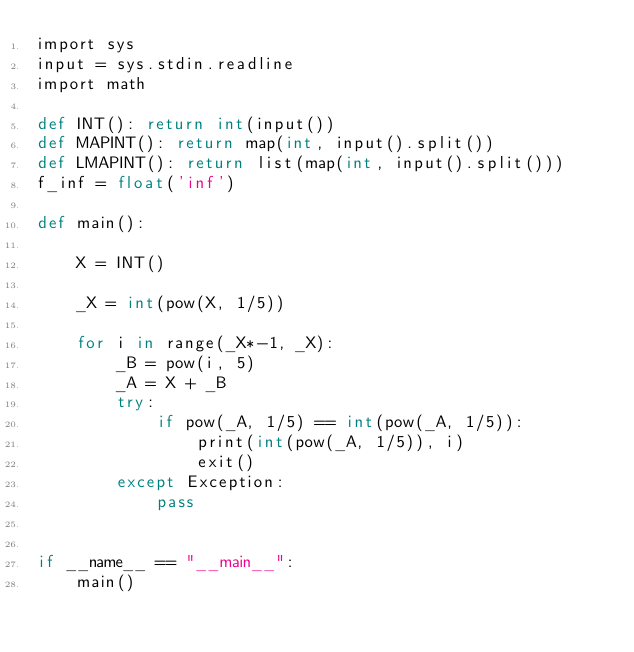Convert code to text. <code><loc_0><loc_0><loc_500><loc_500><_Cython_>import sys
input = sys.stdin.readline
import math

def INT(): return int(input())
def MAPINT(): return map(int, input().split())
def LMAPINT(): return list(map(int, input().split()))
f_inf = float('inf')

def main():

    X = INT()

    _X = int(pow(X, 1/5))

    for i in range(_X*-1, _X):
        _B = pow(i, 5)
        _A = X + _B
        try:
            if pow(_A, 1/5) == int(pow(_A, 1/5)):
                print(int(pow(_A, 1/5)), i)
                exit()
        except Exception:
            pass


if __name__ == "__main__":
    main()</code> 